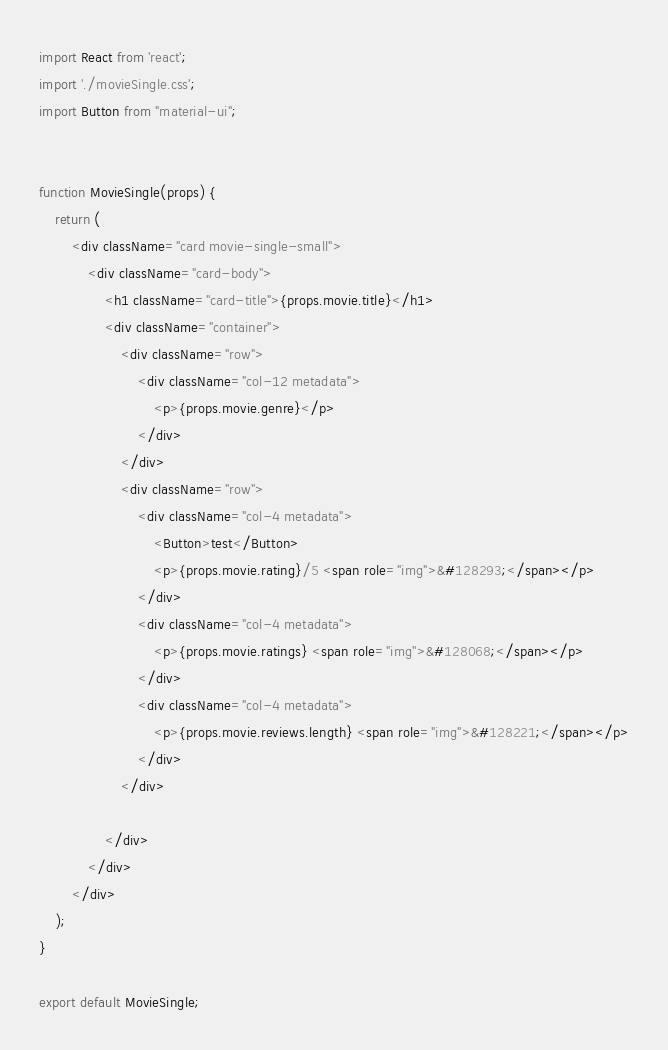<code> <loc_0><loc_0><loc_500><loc_500><_JavaScript_>import React from 'react';
import './movieSingle.css';
import Button from "material-ui";


function MovieSingle(props) {
    return (
        <div className="card movie-single-small">
            <div className="card-body">
                <h1 className="card-title">{props.movie.title}</h1>
                <div className="container">
                    <div className="row">
                        <div className="col-12 metadata">
                            <p>{props.movie.genre}</p>
                        </div>
                    </div>
                    <div className="row">
                        <div className="col-4 metadata">
                            <Button>test</Button>
                            <p>{props.movie.rating}/5 <span role="img">&#128293;</span></p>
                        </div>
                        <div className="col-4 metadata">
                            <p>{props.movie.ratings} <span role="img">&#128068;</span></p>
                        </div>
                        <div className="col-4 metadata">
                            <p>{props.movie.reviews.length} <span role="img">&#128221;</span></p>
                        </div>
                    </div>

                </div>
            </div>
        </div>
    );
}

export default MovieSingle;</code> 